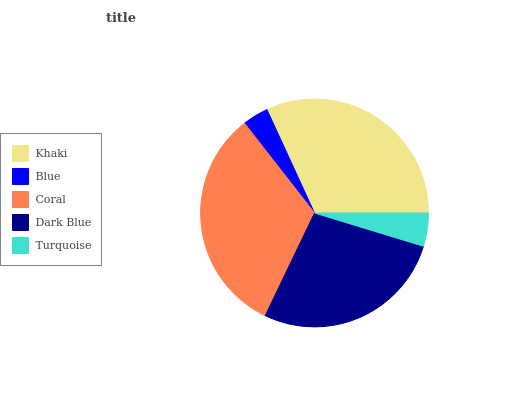Is Blue the minimum?
Answer yes or no. Yes. Is Coral the maximum?
Answer yes or no. Yes. Is Coral the minimum?
Answer yes or no. No. Is Blue the maximum?
Answer yes or no. No. Is Coral greater than Blue?
Answer yes or no. Yes. Is Blue less than Coral?
Answer yes or no. Yes. Is Blue greater than Coral?
Answer yes or no. No. Is Coral less than Blue?
Answer yes or no. No. Is Dark Blue the high median?
Answer yes or no. Yes. Is Dark Blue the low median?
Answer yes or no. Yes. Is Turquoise the high median?
Answer yes or no. No. Is Turquoise the low median?
Answer yes or no. No. 